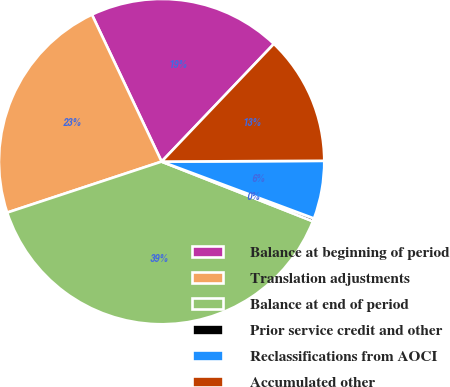<chart> <loc_0><loc_0><loc_500><loc_500><pie_chart><fcel>Balance at beginning of period<fcel>Translation adjustments<fcel>Balance at end of period<fcel>Prior service credit and other<fcel>Reclassifications from AOCI<fcel>Accumulated other<nl><fcel>19.17%<fcel>23.03%<fcel>38.94%<fcel>0.3%<fcel>5.76%<fcel>12.8%<nl></chart> 